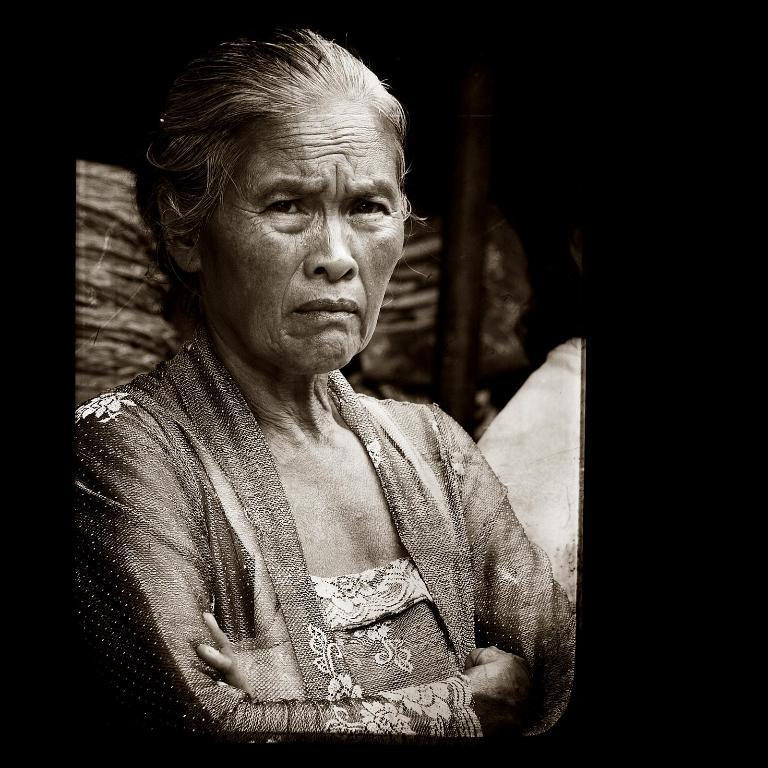Who is present in the image? There is a woman in the image. What is the woman doing in the image? The woman is looking to the left. What can be seen in the background of the image? There is a wooden pole and objects placed behind the woman. Is there anyone else in the image? Yes, there is a person sitting next to the woman. What language is the fan speaking in the image? There is no fan present in the image, so it is not possible to determine what language they might be speaking. 